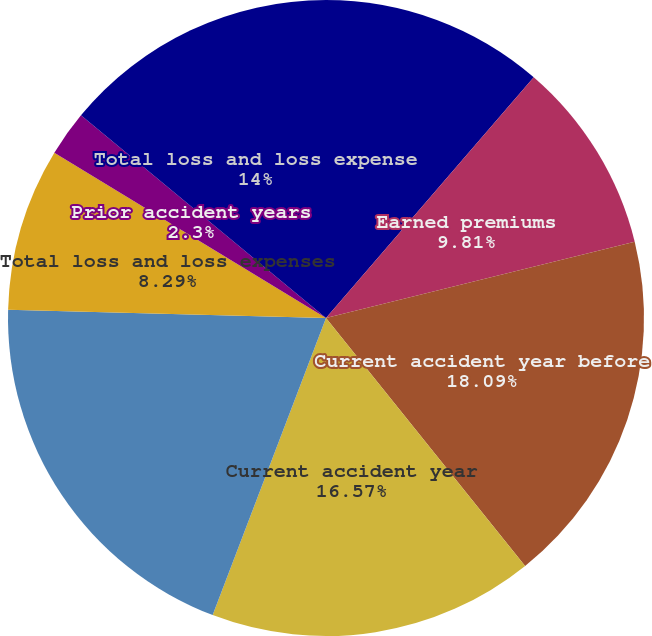<chart> <loc_0><loc_0><loc_500><loc_500><pie_chart><fcel>Net written premiums<fcel>Earned premiums<fcel>Current accident year before<fcel>Current accident year<fcel>Prior accident years before<fcel>Total loss and loss expenses<fcel>Prior accident years<fcel>Total loss and loss expense<nl><fcel>11.33%<fcel>9.81%<fcel>18.09%<fcel>16.57%<fcel>19.61%<fcel>8.29%<fcel>2.3%<fcel>14.0%<nl></chart> 